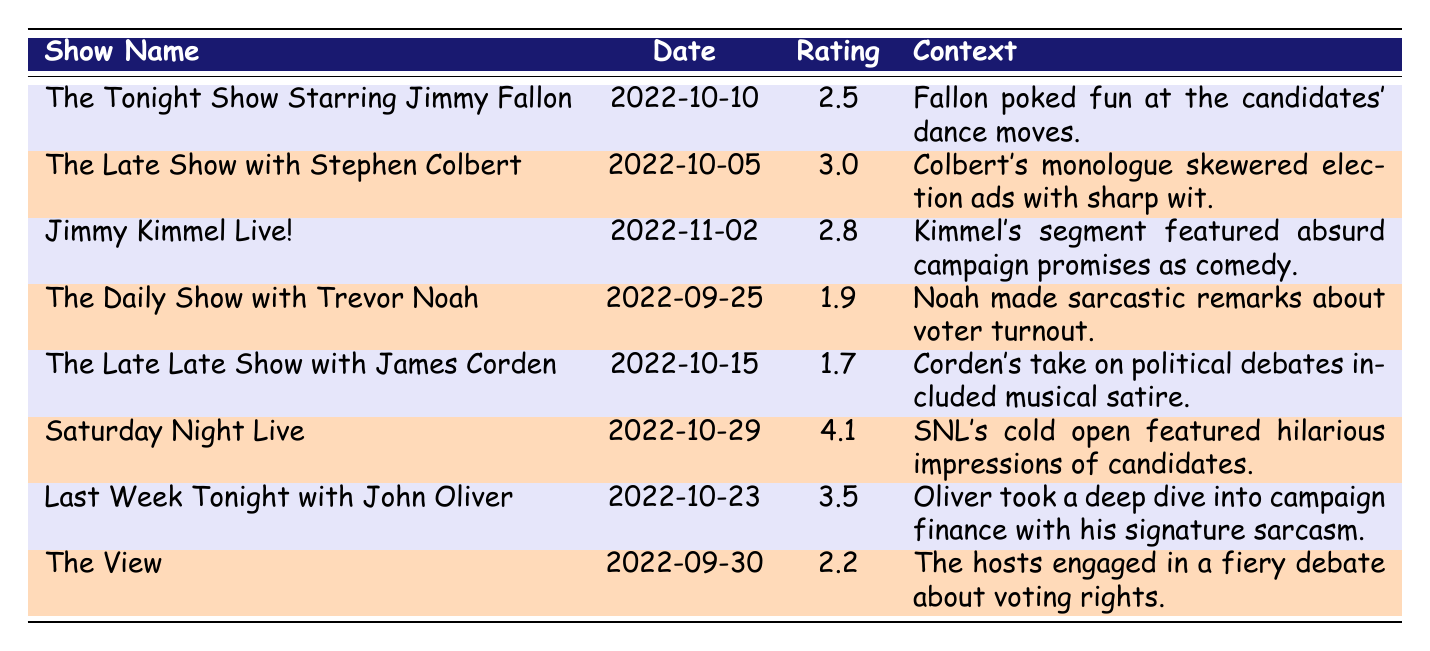What was the highest viewership rating among the late-night shows listed? The data shows that "Saturday Night Live" had the highest rating of 4.1.
Answer: 4.1 Which late-night show had the lowest rating during the 2022 political season? Referring to the table, "The Late Late Show with James Corden" has the lowest rating of 1.7.
Answer: 1.7 What date did "The Daily Show with Trevor Noah" air? The table specifies that "The Daily Show with Trevor Noah" aired on 2022-09-25.
Answer: 2022-09-25 How many shows had a viewership rating higher than 3.0? From the table, "The Late Show with Stephen Colbert" and "Last Week Tonight with John Oliver" have ratings above 3.0, which is a total of 2 shows.
Answer: 2 What was the average viewership rating for the shows listed? To calculate the average: (2.5 + 3.0 + 2.8 + 1.9 + 1.7 + 4.1 + 3.5 + 2.2) = 22.7, and there are 8 shows, so 22.7 / 8 = 2.84.
Answer: 2.84 Did "The Tonight Show Starring Jimmy Fallon" receive a rating below 3.0? Yes, "The Tonight Show Starring Jimmy Fallon" had a rating of 2.5, which is below 3.0.
Answer: Yes Which show's context includes a mention of "sarcasm"? The context for "The Daily Show with Trevor Noah" mentions sarcasm regarding voter turnout.
Answer: The Daily Show with Trevor Noah How many shows had a rating of 2.5 or lower? Referring to the ratings, "The Daily Show with Trevor Noah" (1.9), "The Late Late Show with James Corden" (1.7), and "The Tonight Show Starring Jimmy Fallon" (2.5) had ratings of 2.5 or lower, totaling 3 shows.
Answer: 3 Which show aired closest to the election date in November 2022? "Jimmy Kimmel Live!" aired on November 2, 2022, which is the closest date to the election.
Answer: Jimmy Kimmel Live! What was the context for the show that aired on 2022-10-15? The context for "The Late Late Show with James Corden," which aired on that date, was about musical satire regarding political debates.
Answer: Musical satire regarding political debates 